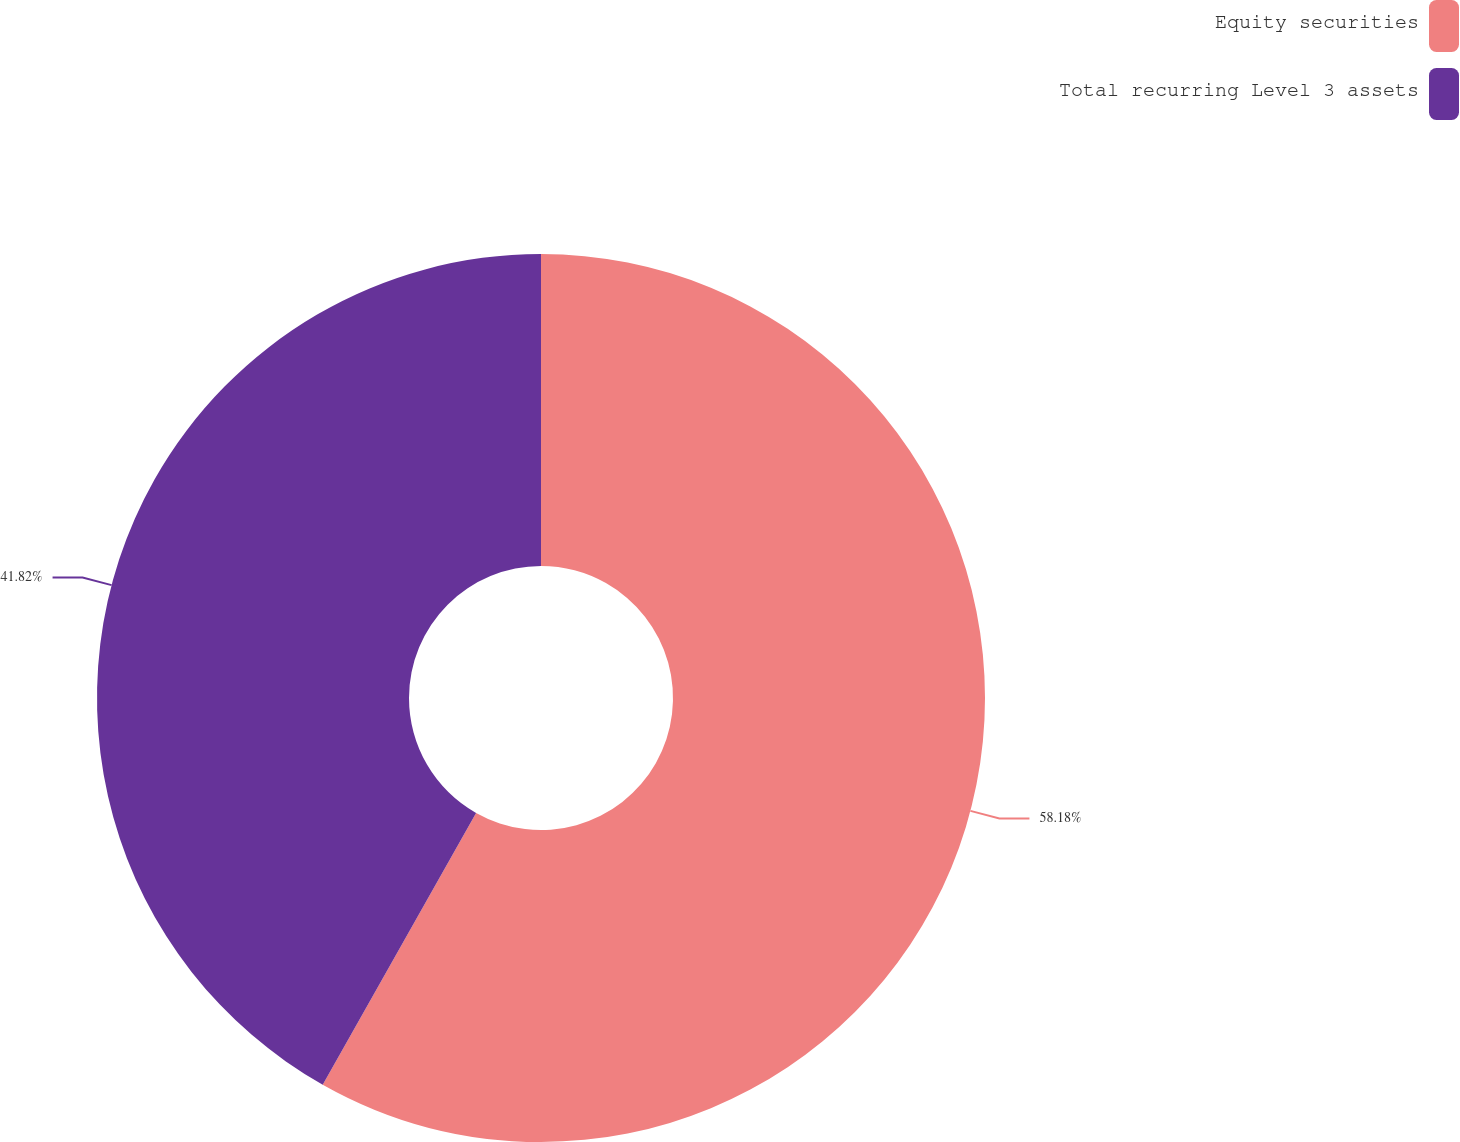Convert chart to OTSL. <chart><loc_0><loc_0><loc_500><loc_500><pie_chart><fcel>Equity securities<fcel>Total recurring Level 3 assets<nl><fcel>58.18%<fcel>41.82%<nl></chart> 